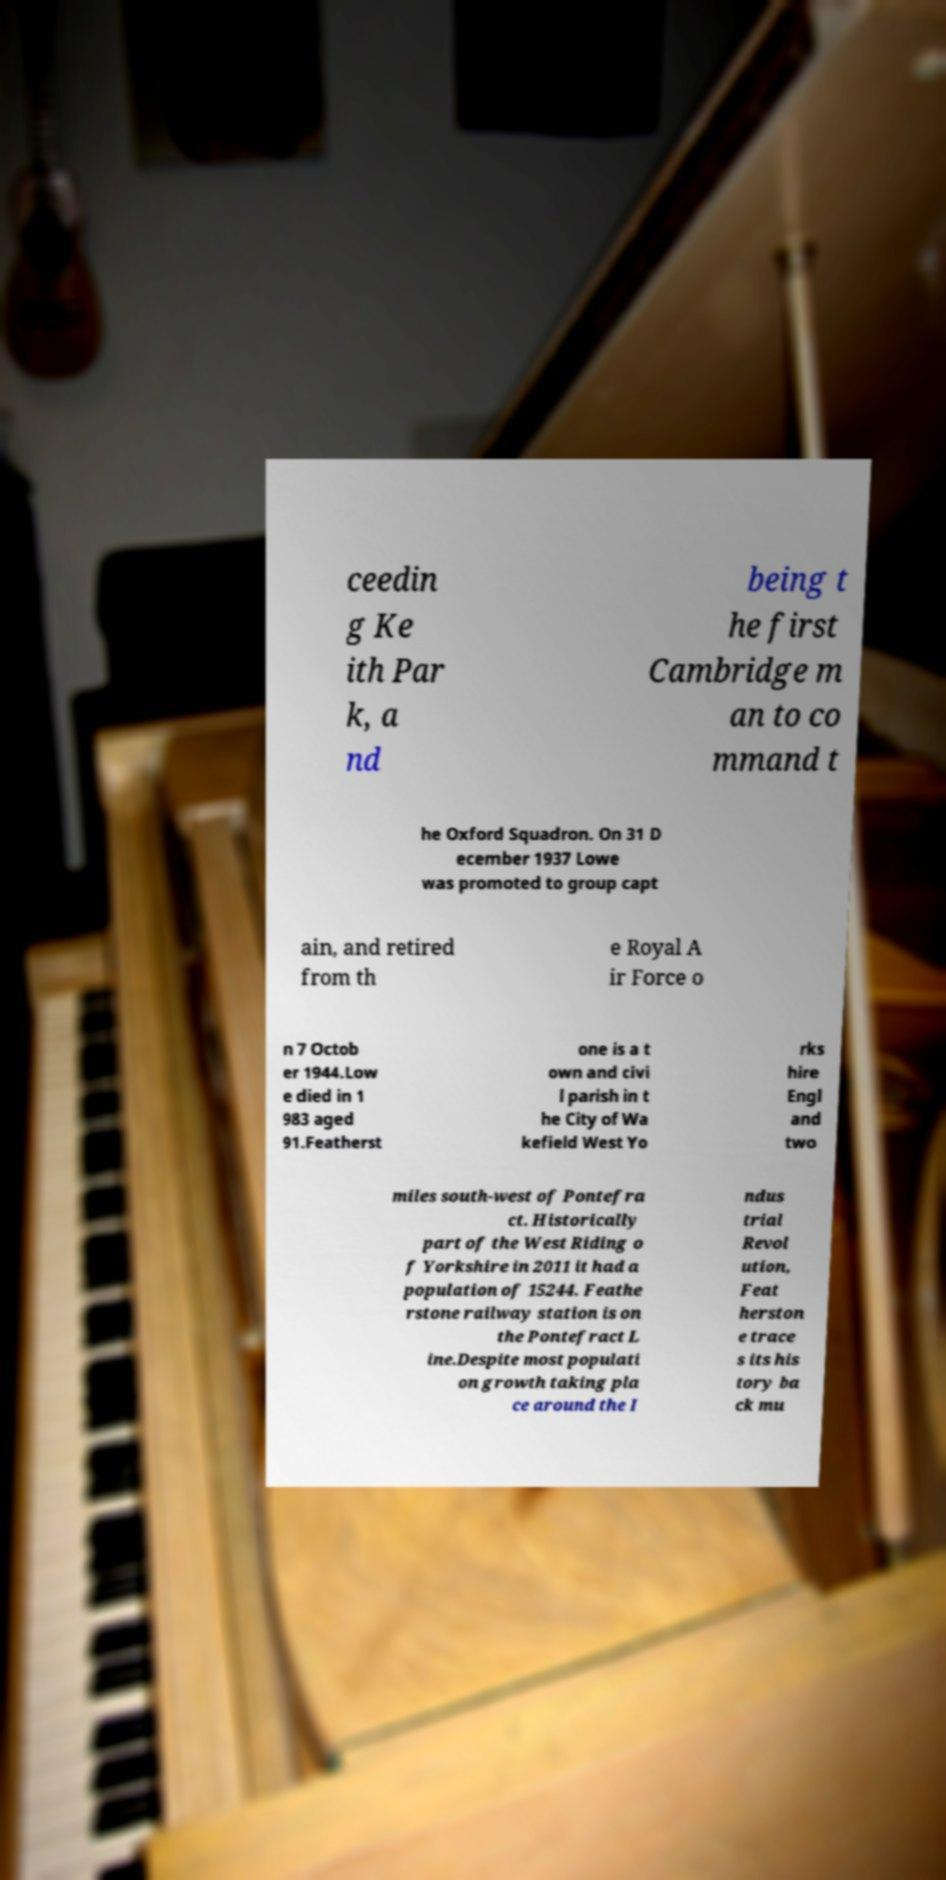I need the written content from this picture converted into text. Can you do that? ceedin g Ke ith Par k, a nd being t he first Cambridge m an to co mmand t he Oxford Squadron. On 31 D ecember 1937 Lowe was promoted to group capt ain, and retired from th e Royal A ir Force o n 7 Octob er 1944.Low e died in 1 983 aged 91.Featherst one is a t own and civi l parish in t he City of Wa kefield West Yo rks hire Engl and two miles south-west of Pontefra ct. Historically part of the West Riding o f Yorkshire in 2011 it had a population of 15244. Feathe rstone railway station is on the Pontefract L ine.Despite most populati on growth taking pla ce around the I ndus trial Revol ution, Feat herston e trace s its his tory ba ck mu 